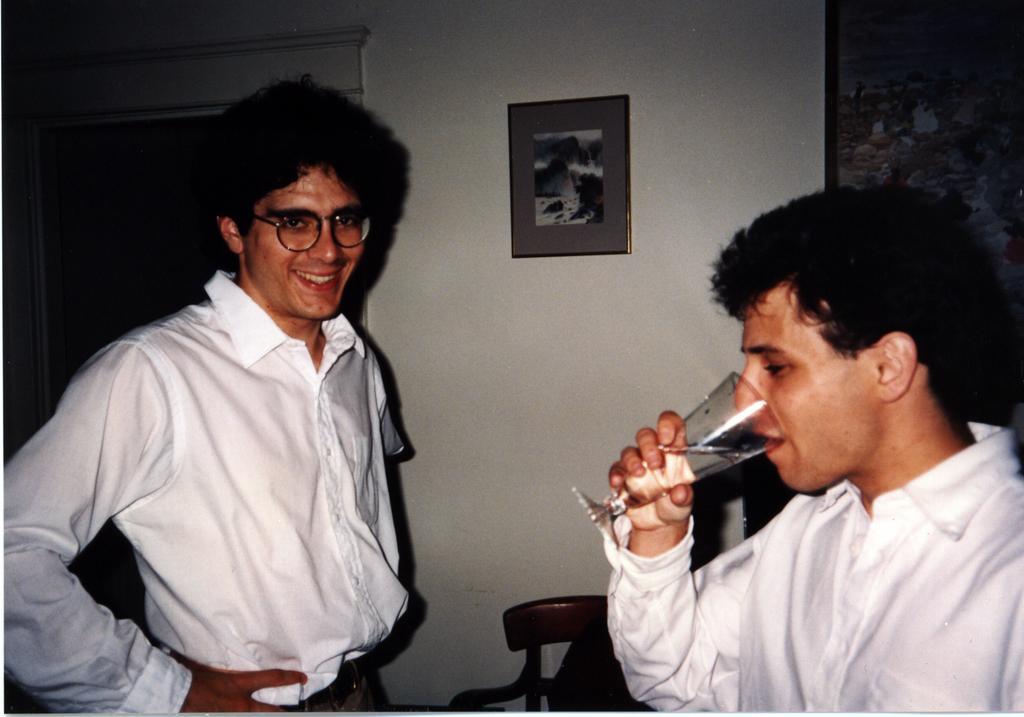Can you describe this image briefly? On the background we can see door , wall and photo frames over it. Here we can see one man wearing white color shirt drinking a glass of water. Here we can see one man standing and smiling. He wore spectacle. 